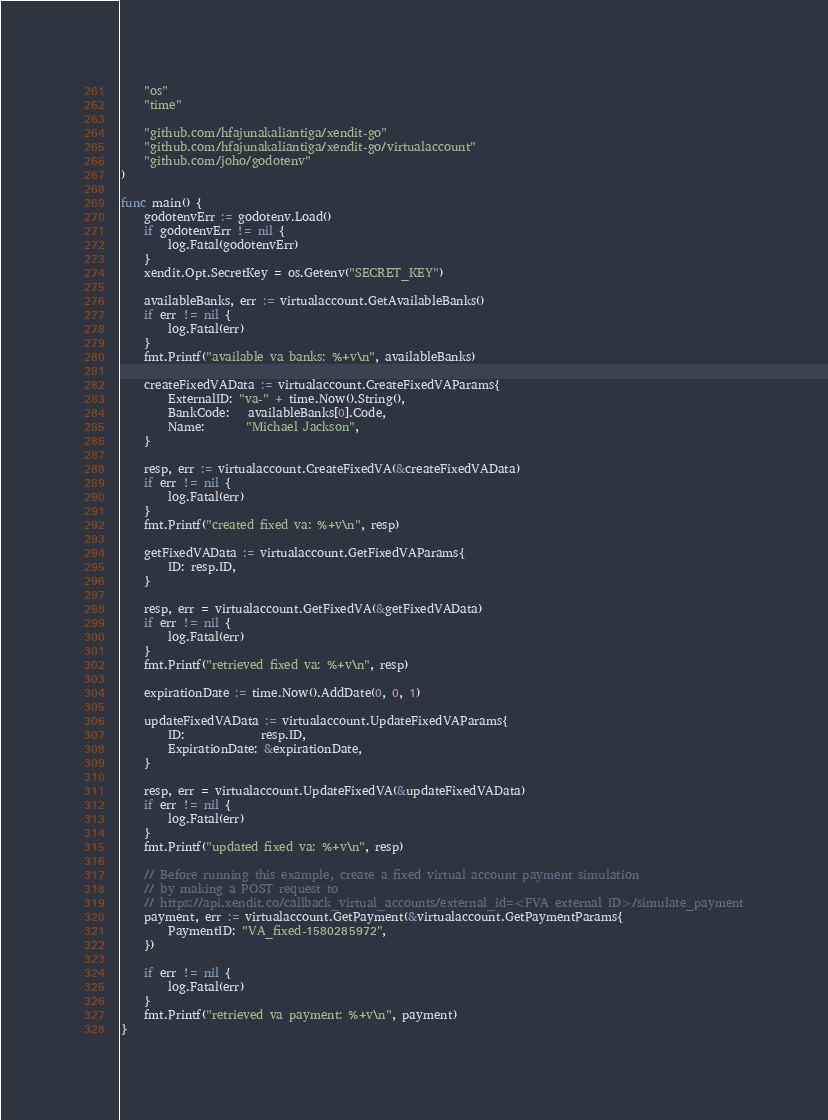<code> <loc_0><loc_0><loc_500><loc_500><_Go_>	"os"
	"time"

	"github.com/hfajunakaliantiga/xendit-go"
	"github.com/hfajunakaliantiga/xendit-go/virtualaccount"
	"github.com/joho/godotenv"
)

func main() {
	godotenvErr := godotenv.Load()
	if godotenvErr != nil {
		log.Fatal(godotenvErr)
	}
	xendit.Opt.SecretKey = os.Getenv("SECRET_KEY")

	availableBanks, err := virtualaccount.GetAvailableBanks()
	if err != nil {
		log.Fatal(err)
	}
	fmt.Printf("available va banks: %+v\n", availableBanks)

	createFixedVAData := virtualaccount.CreateFixedVAParams{
		ExternalID: "va-" + time.Now().String(),
		BankCode:   availableBanks[0].Code,
		Name:       "Michael Jackson",
	}

	resp, err := virtualaccount.CreateFixedVA(&createFixedVAData)
	if err != nil {
		log.Fatal(err)
	}
	fmt.Printf("created fixed va: %+v\n", resp)

	getFixedVAData := virtualaccount.GetFixedVAParams{
		ID: resp.ID,
	}

	resp, err = virtualaccount.GetFixedVA(&getFixedVAData)
	if err != nil {
		log.Fatal(err)
	}
	fmt.Printf("retrieved fixed va: %+v\n", resp)

	expirationDate := time.Now().AddDate(0, 0, 1)

	updateFixedVAData := virtualaccount.UpdateFixedVAParams{
		ID:             resp.ID,
		ExpirationDate: &expirationDate,
	}

	resp, err = virtualaccount.UpdateFixedVA(&updateFixedVAData)
	if err != nil {
		log.Fatal(err)
	}
	fmt.Printf("updated fixed va: %+v\n", resp)

	// Before running this example, create a fixed virtual account payment simulation
	// by making a POST request to
	// https://api.xendit.co/callback_virtual_accounts/external_id=<FVA external ID>/simulate_payment
	payment, err := virtualaccount.GetPayment(&virtualaccount.GetPaymentParams{
		PaymentID: "VA_fixed-1580285972",
	})

	if err != nil {
		log.Fatal(err)
	}
	fmt.Printf("retrieved va payment: %+v\n", payment)
}
</code> 